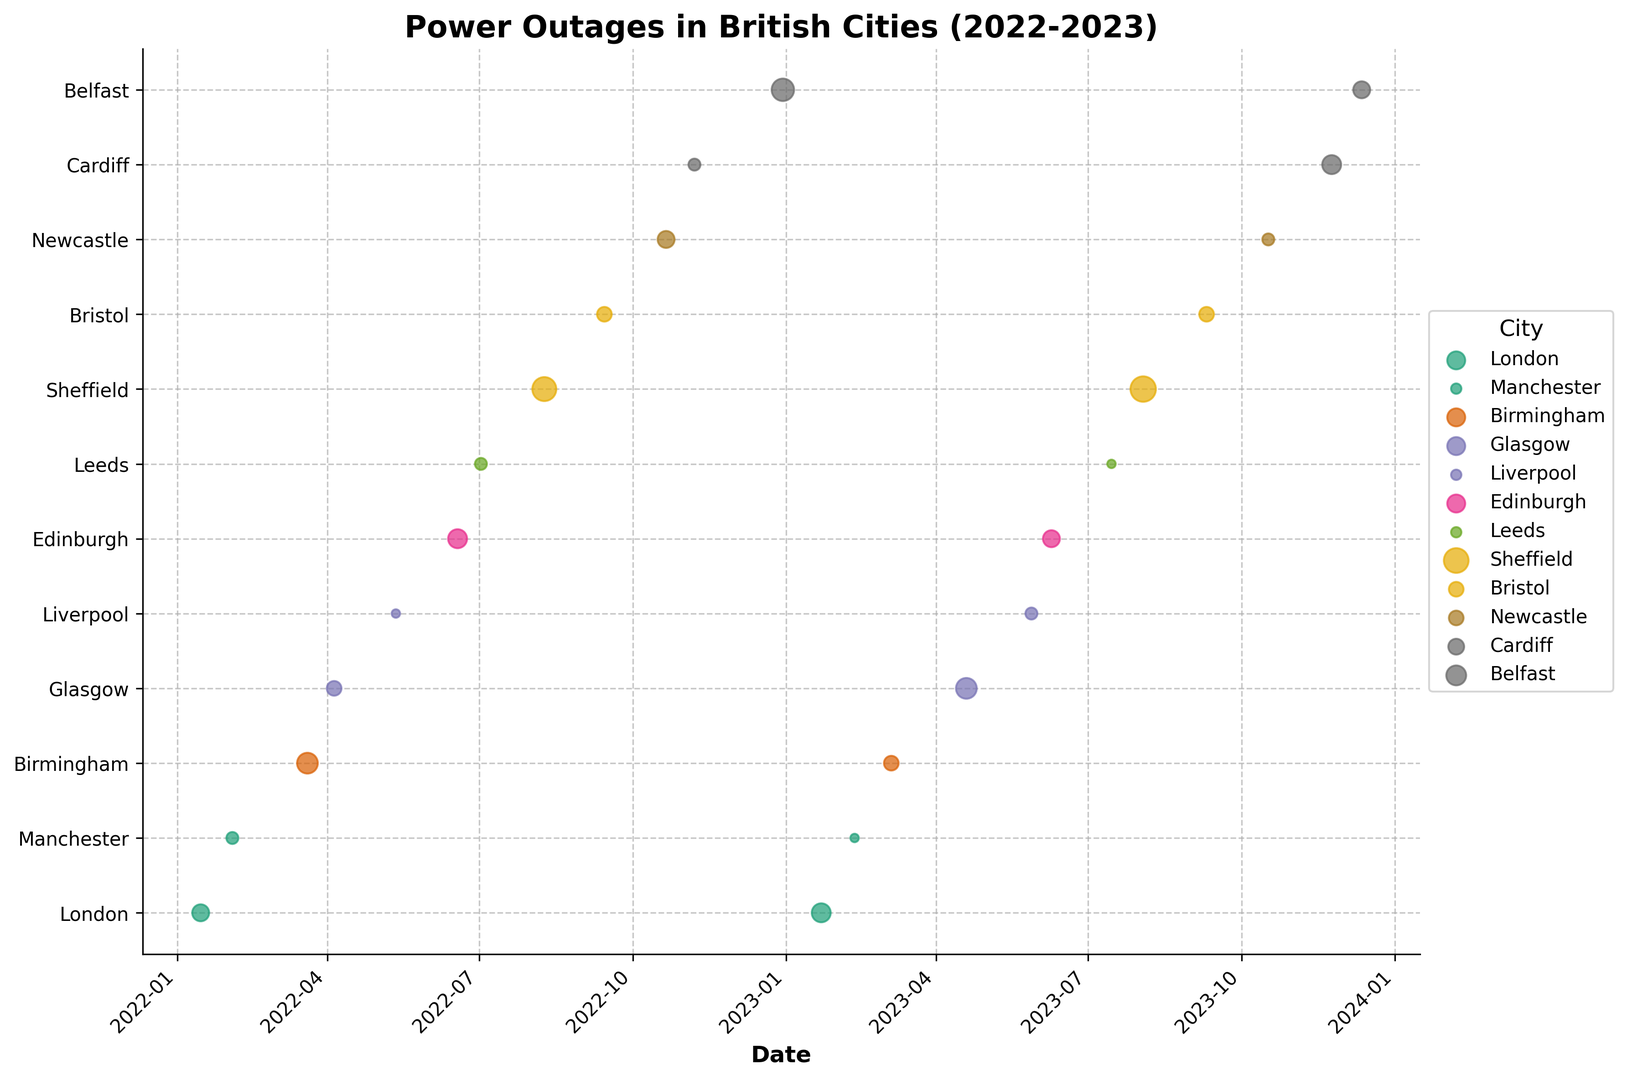Which city had the longest power outage and what was the duration? We can identify the longest outage by looking for the largest point on the plot. The largest point corresponds to Sheffield in August 2023 with a duration of 9 hours.
Answer: Sheffield, 9 hours What is the cause of the longest power outage? The cause can be found by identifying the same city and date (Sheffield, August 2023) on the data table, which indicates the cause as "Heatwave."
Answer: Heatwave Which city experienced the most power outages between 2022 and 2023? By counting the number of points for each city, we notice that London appears the most frequently with two instances.
Answer: London Which months had the highest occurrence of power outages in 2023? Observing the points' dates in 2023, February and July each have two points indicating the highest frequency of outages.
Answer: February and July How many power outages were caused by equipment-related issues? Sum the instances with causes "Equipment Failure," "Equipment Aging," and "Overloaded Transformer." There are three such instances: Manchester (Feb 2022), Birmingham (Mar 2023), and Leeds (Jul 2022).
Answer: 3 What was the average duration of power outages in London? London has two durations: 4 hours (Jan 2022) and 5 hours (Jan 2023). The average is (4 + 5) / 2 = 4.5 hours.
Answer: 4.5 hours Which city had the shortest power outage and when did it occur? The smallest points on the plot represent 1-hour durations, seen in Liverpool (May 2022), Manchester (Feb 2023), and Leeds (Jul 2023).
Answer: Liverpool, Manchester, and Leeds Which cause led to the most power outages? Counting the points associated with each cause, we find that no single cause appears more than twice. Thus, several causes are equally most frequent.
Answer: Several causes In which city did a cyber attack cause a power outage and when? There is only one instance of "Cyber Attack," which occurred in Newcastle in October 2023.
Answer: Newcastle, October 2023 